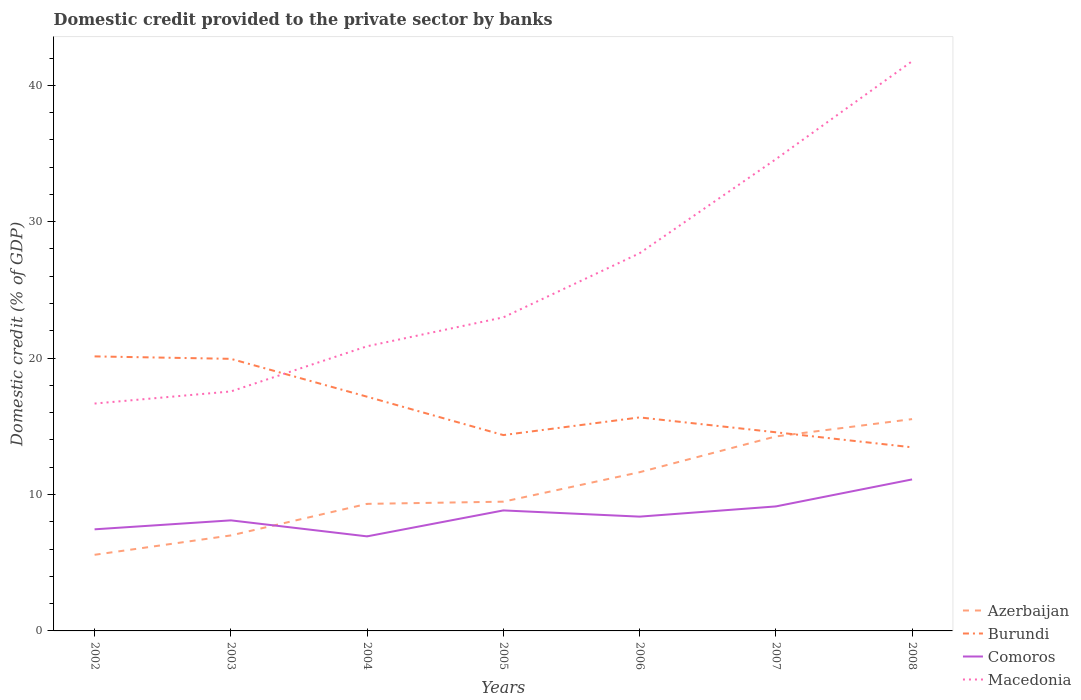How many different coloured lines are there?
Offer a terse response. 4. Across all years, what is the maximum domestic credit provided to the private sector by banks in Comoros?
Your response must be concise. 6.93. In which year was the domestic credit provided to the private sector by banks in Burundi maximum?
Offer a terse response. 2008. What is the total domestic credit provided to the private sector by banks in Comoros in the graph?
Your response must be concise. -1.39. What is the difference between the highest and the second highest domestic credit provided to the private sector by banks in Burundi?
Your answer should be very brief. 6.67. Is the domestic credit provided to the private sector by banks in Burundi strictly greater than the domestic credit provided to the private sector by banks in Comoros over the years?
Give a very brief answer. No. How many lines are there?
Provide a short and direct response. 4. Does the graph contain any zero values?
Your answer should be very brief. No. Does the graph contain grids?
Make the answer very short. No. Where does the legend appear in the graph?
Offer a terse response. Bottom right. How many legend labels are there?
Give a very brief answer. 4. How are the legend labels stacked?
Your answer should be very brief. Vertical. What is the title of the graph?
Ensure brevity in your answer.  Domestic credit provided to the private sector by banks. Does "Myanmar" appear as one of the legend labels in the graph?
Ensure brevity in your answer.  No. What is the label or title of the X-axis?
Offer a very short reply. Years. What is the label or title of the Y-axis?
Your answer should be compact. Domestic credit (% of GDP). What is the Domestic credit (% of GDP) in Azerbaijan in 2002?
Keep it short and to the point. 5.58. What is the Domestic credit (% of GDP) in Burundi in 2002?
Offer a terse response. 20.13. What is the Domestic credit (% of GDP) of Comoros in 2002?
Your answer should be compact. 7.45. What is the Domestic credit (% of GDP) of Macedonia in 2002?
Make the answer very short. 16.67. What is the Domestic credit (% of GDP) in Azerbaijan in 2003?
Give a very brief answer. 7. What is the Domestic credit (% of GDP) in Burundi in 2003?
Offer a terse response. 19.95. What is the Domestic credit (% of GDP) of Comoros in 2003?
Offer a very short reply. 8.11. What is the Domestic credit (% of GDP) in Macedonia in 2003?
Keep it short and to the point. 17.56. What is the Domestic credit (% of GDP) of Azerbaijan in 2004?
Provide a short and direct response. 9.31. What is the Domestic credit (% of GDP) in Burundi in 2004?
Give a very brief answer. 17.17. What is the Domestic credit (% of GDP) of Comoros in 2004?
Offer a terse response. 6.93. What is the Domestic credit (% of GDP) in Macedonia in 2004?
Offer a very short reply. 20.87. What is the Domestic credit (% of GDP) of Azerbaijan in 2005?
Offer a very short reply. 9.48. What is the Domestic credit (% of GDP) in Burundi in 2005?
Your answer should be compact. 14.36. What is the Domestic credit (% of GDP) of Comoros in 2005?
Offer a terse response. 8.83. What is the Domestic credit (% of GDP) in Macedonia in 2005?
Offer a terse response. 22.99. What is the Domestic credit (% of GDP) in Azerbaijan in 2006?
Your response must be concise. 11.64. What is the Domestic credit (% of GDP) in Burundi in 2006?
Give a very brief answer. 15.65. What is the Domestic credit (% of GDP) of Comoros in 2006?
Give a very brief answer. 8.38. What is the Domestic credit (% of GDP) of Macedonia in 2006?
Provide a short and direct response. 27.69. What is the Domestic credit (% of GDP) of Azerbaijan in 2007?
Offer a terse response. 14.26. What is the Domestic credit (% of GDP) in Burundi in 2007?
Your answer should be very brief. 14.56. What is the Domestic credit (% of GDP) in Comoros in 2007?
Your answer should be very brief. 9.13. What is the Domestic credit (% of GDP) of Macedonia in 2007?
Offer a terse response. 34.58. What is the Domestic credit (% of GDP) in Azerbaijan in 2008?
Ensure brevity in your answer.  15.53. What is the Domestic credit (% of GDP) in Burundi in 2008?
Offer a terse response. 13.46. What is the Domestic credit (% of GDP) of Comoros in 2008?
Your answer should be very brief. 11.11. What is the Domestic credit (% of GDP) of Macedonia in 2008?
Give a very brief answer. 41.76. Across all years, what is the maximum Domestic credit (% of GDP) of Azerbaijan?
Your answer should be compact. 15.53. Across all years, what is the maximum Domestic credit (% of GDP) in Burundi?
Provide a succinct answer. 20.13. Across all years, what is the maximum Domestic credit (% of GDP) of Comoros?
Ensure brevity in your answer.  11.11. Across all years, what is the maximum Domestic credit (% of GDP) of Macedonia?
Your answer should be compact. 41.76. Across all years, what is the minimum Domestic credit (% of GDP) of Azerbaijan?
Your answer should be very brief. 5.58. Across all years, what is the minimum Domestic credit (% of GDP) of Burundi?
Make the answer very short. 13.46. Across all years, what is the minimum Domestic credit (% of GDP) in Comoros?
Your answer should be very brief. 6.93. Across all years, what is the minimum Domestic credit (% of GDP) of Macedonia?
Ensure brevity in your answer.  16.67. What is the total Domestic credit (% of GDP) in Azerbaijan in the graph?
Your answer should be compact. 72.79. What is the total Domestic credit (% of GDP) of Burundi in the graph?
Your response must be concise. 115.28. What is the total Domestic credit (% of GDP) in Comoros in the graph?
Your response must be concise. 59.93. What is the total Domestic credit (% of GDP) of Macedonia in the graph?
Offer a terse response. 182.12. What is the difference between the Domestic credit (% of GDP) of Azerbaijan in 2002 and that in 2003?
Make the answer very short. -1.42. What is the difference between the Domestic credit (% of GDP) of Burundi in 2002 and that in 2003?
Make the answer very short. 0.18. What is the difference between the Domestic credit (% of GDP) of Comoros in 2002 and that in 2003?
Provide a succinct answer. -0.66. What is the difference between the Domestic credit (% of GDP) in Macedonia in 2002 and that in 2003?
Provide a short and direct response. -0.89. What is the difference between the Domestic credit (% of GDP) in Azerbaijan in 2002 and that in 2004?
Ensure brevity in your answer.  -3.73. What is the difference between the Domestic credit (% of GDP) of Burundi in 2002 and that in 2004?
Provide a succinct answer. 2.96. What is the difference between the Domestic credit (% of GDP) in Comoros in 2002 and that in 2004?
Make the answer very short. 0.52. What is the difference between the Domestic credit (% of GDP) of Macedonia in 2002 and that in 2004?
Keep it short and to the point. -4.2. What is the difference between the Domestic credit (% of GDP) of Azerbaijan in 2002 and that in 2005?
Keep it short and to the point. -3.89. What is the difference between the Domestic credit (% of GDP) in Burundi in 2002 and that in 2005?
Your answer should be compact. 5.77. What is the difference between the Domestic credit (% of GDP) in Comoros in 2002 and that in 2005?
Keep it short and to the point. -1.39. What is the difference between the Domestic credit (% of GDP) in Macedonia in 2002 and that in 2005?
Your answer should be very brief. -6.32. What is the difference between the Domestic credit (% of GDP) of Azerbaijan in 2002 and that in 2006?
Ensure brevity in your answer.  -6.05. What is the difference between the Domestic credit (% of GDP) in Burundi in 2002 and that in 2006?
Provide a short and direct response. 4.47. What is the difference between the Domestic credit (% of GDP) of Comoros in 2002 and that in 2006?
Provide a short and direct response. -0.93. What is the difference between the Domestic credit (% of GDP) of Macedonia in 2002 and that in 2006?
Offer a very short reply. -11.02. What is the difference between the Domestic credit (% of GDP) in Azerbaijan in 2002 and that in 2007?
Your answer should be very brief. -8.68. What is the difference between the Domestic credit (% of GDP) in Burundi in 2002 and that in 2007?
Keep it short and to the point. 5.56. What is the difference between the Domestic credit (% of GDP) in Comoros in 2002 and that in 2007?
Your answer should be compact. -1.68. What is the difference between the Domestic credit (% of GDP) of Macedonia in 2002 and that in 2007?
Your response must be concise. -17.91. What is the difference between the Domestic credit (% of GDP) in Azerbaijan in 2002 and that in 2008?
Offer a very short reply. -9.95. What is the difference between the Domestic credit (% of GDP) of Burundi in 2002 and that in 2008?
Provide a short and direct response. 6.67. What is the difference between the Domestic credit (% of GDP) in Comoros in 2002 and that in 2008?
Provide a succinct answer. -3.66. What is the difference between the Domestic credit (% of GDP) of Macedonia in 2002 and that in 2008?
Your answer should be compact. -25.09. What is the difference between the Domestic credit (% of GDP) in Azerbaijan in 2003 and that in 2004?
Your answer should be very brief. -2.31. What is the difference between the Domestic credit (% of GDP) of Burundi in 2003 and that in 2004?
Offer a very short reply. 2.78. What is the difference between the Domestic credit (% of GDP) in Comoros in 2003 and that in 2004?
Offer a terse response. 1.17. What is the difference between the Domestic credit (% of GDP) in Macedonia in 2003 and that in 2004?
Make the answer very short. -3.31. What is the difference between the Domestic credit (% of GDP) of Azerbaijan in 2003 and that in 2005?
Ensure brevity in your answer.  -2.47. What is the difference between the Domestic credit (% of GDP) of Burundi in 2003 and that in 2005?
Keep it short and to the point. 5.59. What is the difference between the Domestic credit (% of GDP) of Comoros in 2003 and that in 2005?
Your answer should be very brief. -0.73. What is the difference between the Domestic credit (% of GDP) of Macedonia in 2003 and that in 2005?
Keep it short and to the point. -5.43. What is the difference between the Domestic credit (% of GDP) of Azerbaijan in 2003 and that in 2006?
Offer a terse response. -4.63. What is the difference between the Domestic credit (% of GDP) in Burundi in 2003 and that in 2006?
Offer a terse response. 4.29. What is the difference between the Domestic credit (% of GDP) of Comoros in 2003 and that in 2006?
Provide a short and direct response. -0.27. What is the difference between the Domestic credit (% of GDP) in Macedonia in 2003 and that in 2006?
Make the answer very short. -10.13. What is the difference between the Domestic credit (% of GDP) of Azerbaijan in 2003 and that in 2007?
Keep it short and to the point. -7.26. What is the difference between the Domestic credit (% of GDP) in Burundi in 2003 and that in 2007?
Provide a succinct answer. 5.38. What is the difference between the Domestic credit (% of GDP) in Comoros in 2003 and that in 2007?
Offer a terse response. -1.02. What is the difference between the Domestic credit (% of GDP) of Macedonia in 2003 and that in 2007?
Your answer should be compact. -17.03. What is the difference between the Domestic credit (% of GDP) in Azerbaijan in 2003 and that in 2008?
Make the answer very short. -8.53. What is the difference between the Domestic credit (% of GDP) of Burundi in 2003 and that in 2008?
Keep it short and to the point. 6.49. What is the difference between the Domestic credit (% of GDP) in Comoros in 2003 and that in 2008?
Keep it short and to the point. -3. What is the difference between the Domestic credit (% of GDP) of Macedonia in 2003 and that in 2008?
Ensure brevity in your answer.  -24.21. What is the difference between the Domestic credit (% of GDP) of Azerbaijan in 2004 and that in 2005?
Ensure brevity in your answer.  -0.16. What is the difference between the Domestic credit (% of GDP) of Burundi in 2004 and that in 2005?
Make the answer very short. 2.81. What is the difference between the Domestic credit (% of GDP) of Comoros in 2004 and that in 2005?
Ensure brevity in your answer.  -1.9. What is the difference between the Domestic credit (% of GDP) in Macedonia in 2004 and that in 2005?
Give a very brief answer. -2.12. What is the difference between the Domestic credit (% of GDP) in Azerbaijan in 2004 and that in 2006?
Make the answer very short. -2.32. What is the difference between the Domestic credit (% of GDP) of Burundi in 2004 and that in 2006?
Your response must be concise. 1.52. What is the difference between the Domestic credit (% of GDP) in Comoros in 2004 and that in 2006?
Make the answer very short. -1.45. What is the difference between the Domestic credit (% of GDP) of Macedonia in 2004 and that in 2006?
Your answer should be very brief. -6.82. What is the difference between the Domestic credit (% of GDP) in Azerbaijan in 2004 and that in 2007?
Give a very brief answer. -4.94. What is the difference between the Domestic credit (% of GDP) in Burundi in 2004 and that in 2007?
Offer a terse response. 2.61. What is the difference between the Domestic credit (% of GDP) of Comoros in 2004 and that in 2007?
Provide a succinct answer. -2.2. What is the difference between the Domestic credit (% of GDP) in Macedonia in 2004 and that in 2007?
Ensure brevity in your answer.  -13.71. What is the difference between the Domestic credit (% of GDP) in Azerbaijan in 2004 and that in 2008?
Your answer should be very brief. -6.21. What is the difference between the Domestic credit (% of GDP) of Burundi in 2004 and that in 2008?
Keep it short and to the point. 3.71. What is the difference between the Domestic credit (% of GDP) of Comoros in 2004 and that in 2008?
Provide a short and direct response. -4.18. What is the difference between the Domestic credit (% of GDP) of Macedonia in 2004 and that in 2008?
Ensure brevity in your answer.  -20.9. What is the difference between the Domestic credit (% of GDP) of Azerbaijan in 2005 and that in 2006?
Provide a succinct answer. -2.16. What is the difference between the Domestic credit (% of GDP) of Burundi in 2005 and that in 2006?
Your answer should be compact. -1.3. What is the difference between the Domestic credit (% of GDP) of Comoros in 2005 and that in 2006?
Your answer should be compact. 0.45. What is the difference between the Domestic credit (% of GDP) in Macedonia in 2005 and that in 2006?
Your answer should be compact. -4.7. What is the difference between the Domestic credit (% of GDP) in Azerbaijan in 2005 and that in 2007?
Give a very brief answer. -4.78. What is the difference between the Domestic credit (% of GDP) of Burundi in 2005 and that in 2007?
Your response must be concise. -0.21. What is the difference between the Domestic credit (% of GDP) in Comoros in 2005 and that in 2007?
Offer a terse response. -0.29. What is the difference between the Domestic credit (% of GDP) in Macedonia in 2005 and that in 2007?
Offer a terse response. -11.6. What is the difference between the Domestic credit (% of GDP) in Azerbaijan in 2005 and that in 2008?
Make the answer very short. -6.05. What is the difference between the Domestic credit (% of GDP) of Burundi in 2005 and that in 2008?
Give a very brief answer. 0.9. What is the difference between the Domestic credit (% of GDP) of Comoros in 2005 and that in 2008?
Make the answer very short. -2.27. What is the difference between the Domestic credit (% of GDP) of Macedonia in 2005 and that in 2008?
Your response must be concise. -18.78. What is the difference between the Domestic credit (% of GDP) of Azerbaijan in 2006 and that in 2007?
Keep it short and to the point. -2.62. What is the difference between the Domestic credit (% of GDP) in Burundi in 2006 and that in 2007?
Offer a terse response. 1.09. What is the difference between the Domestic credit (% of GDP) in Comoros in 2006 and that in 2007?
Your response must be concise. -0.75. What is the difference between the Domestic credit (% of GDP) of Macedonia in 2006 and that in 2007?
Your answer should be compact. -6.89. What is the difference between the Domestic credit (% of GDP) in Azerbaijan in 2006 and that in 2008?
Provide a succinct answer. -3.89. What is the difference between the Domestic credit (% of GDP) of Burundi in 2006 and that in 2008?
Your answer should be very brief. 2.19. What is the difference between the Domestic credit (% of GDP) in Comoros in 2006 and that in 2008?
Offer a very short reply. -2.73. What is the difference between the Domestic credit (% of GDP) in Macedonia in 2006 and that in 2008?
Make the answer very short. -14.08. What is the difference between the Domestic credit (% of GDP) of Azerbaijan in 2007 and that in 2008?
Give a very brief answer. -1.27. What is the difference between the Domestic credit (% of GDP) of Burundi in 2007 and that in 2008?
Offer a terse response. 1.1. What is the difference between the Domestic credit (% of GDP) in Comoros in 2007 and that in 2008?
Offer a terse response. -1.98. What is the difference between the Domestic credit (% of GDP) of Macedonia in 2007 and that in 2008?
Your answer should be compact. -7.18. What is the difference between the Domestic credit (% of GDP) in Azerbaijan in 2002 and the Domestic credit (% of GDP) in Burundi in 2003?
Your response must be concise. -14.37. What is the difference between the Domestic credit (% of GDP) in Azerbaijan in 2002 and the Domestic credit (% of GDP) in Comoros in 2003?
Provide a succinct answer. -2.52. What is the difference between the Domestic credit (% of GDP) of Azerbaijan in 2002 and the Domestic credit (% of GDP) of Macedonia in 2003?
Provide a succinct answer. -11.98. What is the difference between the Domestic credit (% of GDP) of Burundi in 2002 and the Domestic credit (% of GDP) of Comoros in 2003?
Offer a terse response. 12.02. What is the difference between the Domestic credit (% of GDP) in Burundi in 2002 and the Domestic credit (% of GDP) in Macedonia in 2003?
Ensure brevity in your answer.  2.57. What is the difference between the Domestic credit (% of GDP) in Comoros in 2002 and the Domestic credit (% of GDP) in Macedonia in 2003?
Offer a very short reply. -10.11. What is the difference between the Domestic credit (% of GDP) of Azerbaijan in 2002 and the Domestic credit (% of GDP) of Burundi in 2004?
Your response must be concise. -11.59. What is the difference between the Domestic credit (% of GDP) of Azerbaijan in 2002 and the Domestic credit (% of GDP) of Comoros in 2004?
Offer a terse response. -1.35. What is the difference between the Domestic credit (% of GDP) in Azerbaijan in 2002 and the Domestic credit (% of GDP) in Macedonia in 2004?
Offer a terse response. -15.29. What is the difference between the Domestic credit (% of GDP) of Burundi in 2002 and the Domestic credit (% of GDP) of Comoros in 2004?
Ensure brevity in your answer.  13.19. What is the difference between the Domestic credit (% of GDP) of Burundi in 2002 and the Domestic credit (% of GDP) of Macedonia in 2004?
Keep it short and to the point. -0.74. What is the difference between the Domestic credit (% of GDP) of Comoros in 2002 and the Domestic credit (% of GDP) of Macedonia in 2004?
Your response must be concise. -13.42. What is the difference between the Domestic credit (% of GDP) of Azerbaijan in 2002 and the Domestic credit (% of GDP) of Burundi in 2005?
Give a very brief answer. -8.78. What is the difference between the Domestic credit (% of GDP) in Azerbaijan in 2002 and the Domestic credit (% of GDP) in Comoros in 2005?
Give a very brief answer. -3.25. What is the difference between the Domestic credit (% of GDP) in Azerbaijan in 2002 and the Domestic credit (% of GDP) in Macedonia in 2005?
Offer a terse response. -17.41. What is the difference between the Domestic credit (% of GDP) of Burundi in 2002 and the Domestic credit (% of GDP) of Comoros in 2005?
Your answer should be very brief. 11.29. What is the difference between the Domestic credit (% of GDP) of Burundi in 2002 and the Domestic credit (% of GDP) of Macedonia in 2005?
Provide a succinct answer. -2.86. What is the difference between the Domestic credit (% of GDP) of Comoros in 2002 and the Domestic credit (% of GDP) of Macedonia in 2005?
Keep it short and to the point. -15.54. What is the difference between the Domestic credit (% of GDP) in Azerbaijan in 2002 and the Domestic credit (% of GDP) in Burundi in 2006?
Your answer should be very brief. -10.07. What is the difference between the Domestic credit (% of GDP) in Azerbaijan in 2002 and the Domestic credit (% of GDP) in Comoros in 2006?
Your response must be concise. -2.8. What is the difference between the Domestic credit (% of GDP) of Azerbaijan in 2002 and the Domestic credit (% of GDP) of Macedonia in 2006?
Make the answer very short. -22.11. What is the difference between the Domestic credit (% of GDP) in Burundi in 2002 and the Domestic credit (% of GDP) in Comoros in 2006?
Make the answer very short. 11.75. What is the difference between the Domestic credit (% of GDP) of Burundi in 2002 and the Domestic credit (% of GDP) of Macedonia in 2006?
Offer a terse response. -7.56. What is the difference between the Domestic credit (% of GDP) in Comoros in 2002 and the Domestic credit (% of GDP) in Macedonia in 2006?
Your answer should be very brief. -20.24. What is the difference between the Domestic credit (% of GDP) of Azerbaijan in 2002 and the Domestic credit (% of GDP) of Burundi in 2007?
Your answer should be compact. -8.98. What is the difference between the Domestic credit (% of GDP) in Azerbaijan in 2002 and the Domestic credit (% of GDP) in Comoros in 2007?
Offer a very short reply. -3.55. What is the difference between the Domestic credit (% of GDP) in Azerbaijan in 2002 and the Domestic credit (% of GDP) in Macedonia in 2007?
Keep it short and to the point. -29. What is the difference between the Domestic credit (% of GDP) in Burundi in 2002 and the Domestic credit (% of GDP) in Comoros in 2007?
Make the answer very short. 11. What is the difference between the Domestic credit (% of GDP) of Burundi in 2002 and the Domestic credit (% of GDP) of Macedonia in 2007?
Make the answer very short. -14.46. What is the difference between the Domestic credit (% of GDP) of Comoros in 2002 and the Domestic credit (% of GDP) of Macedonia in 2007?
Keep it short and to the point. -27.13. What is the difference between the Domestic credit (% of GDP) in Azerbaijan in 2002 and the Domestic credit (% of GDP) in Burundi in 2008?
Keep it short and to the point. -7.88. What is the difference between the Domestic credit (% of GDP) of Azerbaijan in 2002 and the Domestic credit (% of GDP) of Comoros in 2008?
Your answer should be very brief. -5.53. What is the difference between the Domestic credit (% of GDP) of Azerbaijan in 2002 and the Domestic credit (% of GDP) of Macedonia in 2008?
Provide a succinct answer. -36.18. What is the difference between the Domestic credit (% of GDP) of Burundi in 2002 and the Domestic credit (% of GDP) of Comoros in 2008?
Offer a terse response. 9.02. What is the difference between the Domestic credit (% of GDP) of Burundi in 2002 and the Domestic credit (% of GDP) of Macedonia in 2008?
Offer a very short reply. -21.64. What is the difference between the Domestic credit (% of GDP) in Comoros in 2002 and the Domestic credit (% of GDP) in Macedonia in 2008?
Ensure brevity in your answer.  -34.32. What is the difference between the Domestic credit (% of GDP) in Azerbaijan in 2003 and the Domestic credit (% of GDP) in Burundi in 2004?
Your answer should be very brief. -10.17. What is the difference between the Domestic credit (% of GDP) in Azerbaijan in 2003 and the Domestic credit (% of GDP) in Comoros in 2004?
Give a very brief answer. 0.07. What is the difference between the Domestic credit (% of GDP) in Azerbaijan in 2003 and the Domestic credit (% of GDP) in Macedonia in 2004?
Make the answer very short. -13.87. What is the difference between the Domestic credit (% of GDP) of Burundi in 2003 and the Domestic credit (% of GDP) of Comoros in 2004?
Your response must be concise. 13.02. What is the difference between the Domestic credit (% of GDP) of Burundi in 2003 and the Domestic credit (% of GDP) of Macedonia in 2004?
Offer a very short reply. -0.92. What is the difference between the Domestic credit (% of GDP) of Comoros in 2003 and the Domestic credit (% of GDP) of Macedonia in 2004?
Ensure brevity in your answer.  -12.76. What is the difference between the Domestic credit (% of GDP) of Azerbaijan in 2003 and the Domestic credit (% of GDP) of Burundi in 2005?
Provide a succinct answer. -7.36. What is the difference between the Domestic credit (% of GDP) of Azerbaijan in 2003 and the Domestic credit (% of GDP) of Comoros in 2005?
Provide a short and direct response. -1.83. What is the difference between the Domestic credit (% of GDP) in Azerbaijan in 2003 and the Domestic credit (% of GDP) in Macedonia in 2005?
Your answer should be very brief. -15.99. What is the difference between the Domestic credit (% of GDP) in Burundi in 2003 and the Domestic credit (% of GDP) in Comoros in 2005?
Provide a succinct answer. 11.11. What is the difference between the Domestic credit (% of GDP) of Burundi in 2003 and the Domestic credit (% of GDP) of Macedonia in 2005?
Provide a short and direct response. -3.04. What is the difference between the Domestic credit (% of GDP) in Comoros in 2003 and the Domestic credit (% of GDP) in Macedonia in 2005?
Keep it short and to the point. -14.88. What is the difference between the Domestic credit (% of GDP) in Azerbaijan in 2003 and the Domestic credit (% of GDP) in Burundi in 2006?
Offer a very short reply. -8.65. What is the difference between the Domestic credit (% of GDP) of Azerbaijan in 2003 and the Domestic credit (% of GDP) of Comoros in 2006?
Provide a short and direct response. -1.38. What is the difference between the Domestic credit (% of GDP) of Azerbaijan in 2003 and the Domestic credit (% of GDP) of Macedonia in 2006?
Offer a very short reply. -20.69. What is the difference between the Domestic credit (% of GDP) of Burundi in 2003 and the Domestic credit (% of GDP) of Comoros in 2006?
Your answer should be very brief. 11.57. What is the difference between the Domestic credit (% of GDP) in Burundi in 2003 and the Domestic credit (% of GDP) in Macedonia in 2006?
Ensure brevity in your answer.  -7.74. What is the difference between the Domestic credit (% of GDP) of Comoros in 2003 and the Domestic credit (% of GDP) of Macedonia in 2006?
Your response must be concise. -19.58. What is the difference between the Domestic credit (% of GDP) of Azerbaijan in 2003 and the Domestic credit (% of GDP) of Burundi in 2007?
Make the answer very short. -7.56. What is the difference between the Domestic credit (% of GDP) in Azerbaijan in 2003 and the Domestic credit (% of GDP) in Comoros in 2007?
Give a very brief answer. -2.13. What is the difference between the Domestic credit (% of GDP) of Azerbaijan in 2003 and the Domestic credit (% of GDP) of Macedonia in 2007?
Offer a terse response. -27.58. What is the difference between the Domestic credit (% of GDP) in Burundi in 2003 and the Domestic credit (% of GDP) in Comoros in 2007?
Your answer should be very brief. 10.82. What is the difference between the Domestic credit (% of GDP) in Burundi in 2003 and the Domestic credit (% of GDP) in Macedonia in 2007?
Your answer should be compact. -14.64. What is the difference between the Domestic credit (% of GDP) in Comoros in 2003 and the Domestic credit (% of GDP) in Macedonia in 2007?
Keep it short and to the point. -26.48. What is the difference between the Domestic credit (% of GDP) in Azerbaijan in 2003 and the Domestic credit (% of GDP) in Burundi in 2008?
Your answer should be compact. -6.46. What is the difference between the Domestic credit (% of GDP) of Azerbaijan in 2003 and the Domestic credit (% of GDP) of Comoros in 2008?
Your answer should be very brief. -4.11. What is the difference between the Domestic credit (% of GDP) in Azerbaijan in 2003 and the Domestic credit (% of GDP) in Macedonia in 2008?
Provide a succinct answer. -34.76. What is the difference between the Domestic credit (% of GDP) of Burundi in 2003 and the Domestic credit (% of GDP) of Comoros in 2008?
Your answer should be compact. 8.84. What is the difference between the Domestic credit (% of GDP) of Burundi in 2003 and the Domestic credit (% of GDP) of Macedonia in 2008?
Keep it short and to the point. -21.82. What is the difference between the Domestic credit (% of GDP) in Comoros in 2003 and the Domestic credit (% of GDP) in Macedonia in 2008?
Provide a succinct answer. -33.66. What is the difference between the Domestic credit (% of GDP) in Azerbaijan in 2004 and the Domestic credit (% of GDP) in Burundi in 2005?
Ensure brevity in your answer.  -5.04. What is the difference between the Domestic credit (% of GDP) in Azerbaijan in 2004 and the Domestic credit (% of GDP) in Comoros in 2005?
Provide a succinct answer. 0.48. What is the difference between the Domestic credit (% of GDP) in Azerbaijan in 2004 and the Domestic credit (% of GDP) in Macedonia in 2005?
Make the answer very short. -13.67. What is the difference between the Domestic credit (% of GDP) in Burundi in 2004 and the Domestic credit (% of GDP) in Comoros in 2005?
Provide a succinct answer. 8.34. What is the difference between the Domestic credit (% of GDP) of Burundi in 2004 and the Domestic credit (% of GDP) of Macedonia in 2005?
Give a very brief answer. -5.82. What is the difference between the Domestic credit (% of GDP) of Comoros in 2004 and the Domestic credit (% of GDP) of Macedonia in 2005?
Your answer should be compact. -16.06. What is the difference between the Domestic credit (% of GDP) in Azerbaijan in 2004 and the Domestic credit (% of GDP) in Burundi in 2006?
Your response must be concise. -6.34. What is the difference between the Domestic credit (% of GDP) in Azerbaijan in 2004 and the Domestic credit (% of GDP) in Comoros in 2006?
Provide a succinct answer. 0.94. What is the difference between the Domestic credit (% of GDP) in Azerbaijan in 2004 and the Domestic credit (% of GDP) in Macedonia in 2006?
Provide a short and direct response. -18.37. What is the difference between the Domestic credit (% of GDP) of Burundi in 2004 and the Domestic credit (% of GDP) of Comoros in 2006?
Give a very brief answer. 8.79. What is the difference between the Domestic credit (% of GDP) in Burundi in 2004 and the Domestic credit (% of GDP) in Macedonia in 2006?
Provide a short and direct response. -10.52. What is the difference between the Domestic credit (% of GDP) in Comoros in 2004 and the Domestic credit (% of GDP) in Macedonia in 2006?
Keep it short and to the point. -20.76. What is the difference between the Domestic credit (% of GDP) of Azerbaijan in 2004 and the Domestic credit (% of GDP) of Burundi in 2007?
Offer a terse response. -5.25. What is the difference between the Domestic credit (% of GDP) in Azerbaijan in 2004 and the Domestic credit (% of GDP) in Comoros in 2007?
Ensure brevity in your answer.  0.19. What is the difference between the Domestic credit (% of GDP) of Azerbaijan in 2004 and the Domestic credit (% of GDP) of Macedonia in 2007?
Offer a terse response. -25.27. What is the difference between the Domestic credit (% of GDP) of Burundi in 2004 and the Domestic credit (% of GDP) of Comoros in 2007?
Make the answer very short. 8.04. What is the difference between the Domestic credit (% of GDP) in Burundi in 2004 and the Domestic credit (% of GDP) in Macedonia in 2007?
Your response must be concise. -17.41. What is the difference between the Domestic credit (% of GDP) in Comoros in 2004 and the Domestic credit (% of GDP) in Macedonia in 2007?
Provide a succinct answer. -27.65. What is the difference between the Domestic credit (% of GDP) in Azerbaijan in 2004 and the Domestic credit (% of GDP) in Burundi in 2008?
Keep it short and to the point. -4.15. What is the difference between the Domestic credit (% of GDP) of Azerbaijan in 2004 and the Domestic credit (% of GDP) of Comoros in 2008?
Offer a very short reply. -1.79. What is the difference between the Domestic credit (% of GDP) in Azerbaijan in 2004 and the Domestic credit (% of GDP) in Macedonia in 2008?
Your answer should be compact. -32.45. What is the difference between the Domestic credit (% of GDP) of Burundi in 2004 and the Domestic credit (% of GDP) of Comoros in 2008?
Your answer should be very brief. 6.06. What is the difference between the Domestic credit (% of GDP) in Burundi in 2004 and the Domestic credit (% of GDP) in Macedonia in 2008?
Keep it short and to the point. -24.59. What is the difference between the Domestic credit (% of GDP) of Comoros in 2004 and the Domestic credit (% of GDP) of Macedonia in 2008?
Keep it short and to the point. -34.83. What is the difference between the Domestic credit (% of GDP) in Azerbaijan in 2005 and the Domestic credit (% of GDP) in Burundi in 2006?
Ensure brevity in your answer.  -6.18. What is the difference between the Domestic credit (% of GDP) in Azerbaijan in 2005 and the Domestic credit (% of GDP) in Comoros in 2006?
Make the answer very short. 1.1. What is the difference between the Domestic credit (% of GDP) in Azerbaijan in 2005 and the Domestic credit (% of GDP) in Macedonia in 2006?
Give a very brief answer. -18.21. What is the difference between the Domestic credit (% of GDP) in Burundi in 2005 and the Domestic credit (% of GDP) in Comoros in 2006?
Ensure brevity in your answer.  5.98. What is the difference between the Domestic credit (% of GDP) of Burundi in 2005 and the Domestic credit (% of GDP) of Macedonia in 2006?
Make the answer very short. -13.33. What is the difference between the Domestic credit (% of GDP) of Comoros in 2005 and the Domestic credit (% of GDP) of Macedonia in 2006?
Your response must be concise. -18.85. What is the difference between the Domestic credit (% of GDP) of Azerbaijan in 2005 and the Domestic credit (% of GDP) of Burundi in 2007?
Ensure brevity in your answer.  -5.09. What is the difference between the Domestic credit (% of GDP) of Azerbaijan in 2005 and the Domestic credit (% of GDP) of Comoros in 2007?
Your answer should be compact. 0.35. What is the difference between the Domestic credit (% of GDP) of Azerbaijan in 2005 and the Domestic credit (% of GDP) of Macedonia in 2007?
Make the answer very short. -25.11. What is the difference between the Domestic credit (% of GDP) in Burundi in 2005 and the Domestic credit (% of GDP) in Comoros in 2007?
Ensure brevity in your answer.  5.23. What is the difference between the Domestic credit (% of GDP) of Burundi in 2005 and the Domestic credit (% of GDP) of Macedonia in 2007?
Offer a very short reply. -20.23. What is the difference between the Domestic credit (% of GDP) in Comoros in 2005 and the Domestic credit (% of GDP) in Macedonia in 2007?
Provide a succinct answer. -25.75. What is the difference between the Domestic credit (% of GDP) of Azerbaijan in 2005 and the Domestic credit (% of GDP) of Burundi in 2008?
Provide a short and direct response. -3.99. What is the difference between the Domestic credit (% of GDP) of Azerbaijan in 2005 and the Domestic credit (% of GDP) of Comoros in 2008?
Offer a very short reply. -1.63. What is the difference between the Domestic credit (% of GDP) in Azerbaijan in 2005 and the Domestic credit (% of GDP) in Macedonia in 2008?
Offer a terse response. -32.29. What is the difference between the Domestic credit (% of GDP) of Burundi in 2005 and the Domestic credit (% of GDP) of Comoros in 2008?
Keep it short and to the point. 3.25. What is the difference between the Domestic credit (% of GDP) of Burundi in 2005 and the Domestic credit (% of GDP) of Macedonia in 2008?
Your response must be concise. -27.41. What is the difference between the Domestic credit (% of GDP) in Comoros in 2005 and the Domestic credit (% of GDP) in Macedonia in 2008?
Your answer should be compact. -32.93. What is the difference between the Domestic credit (% of GDP) in Azerbaijan in 2006 and the Domestic credit (% of GDP) in Burundi in 2007?
Offer a very short reply. -2.93. What is the difference between the Domestic credit (% of GDP) of Azerbaijan in 2006 and the Domestic credit (% of GDP) of Comoros in 2007?
Offer a terse response. 2.51. What is the difference between the Domestic credit (% of GDP) in Azerbaijan in 2006 and the Domestic credit (% of GDP) in Macedonia in 2007?
Give a very brief answer. -22.95. What is the difference between the Domestic credit (% of GDP) in Burundi in 2006 and the Domestic credit (% of GDP) in Comoros in 2007?
Ensure brevity in your answer.  6.53. What is the difference between the Domestic credit (% of GDP) of Burundi in 2006 and the Domestic credit (% of GDP) of Macedonia in 2007?
Your response must be concise. -18.93. What is the difference between the Domestic credit (% of GDP) of Comoros in 2006 and the Domestic credit (% of GDP) of Macedonia in 2007?
Offer a very short reply. -26.2. What is the difference between the Domestic credit (% of GDP) in Azerbaijan in 2006 and the Domestic credit (% of GDP) in Burundi in 2008?
Keep it short and to the point. -1.83. What is the difference between the Domestic credit (% of GDP) of Azerbaijan in 2006 and the Domestic credit (% of GDP) of Comoros in 2008?
Your answer should be compact. 0.53. What is the difference between the Domestic credit (% of GDP) in Azerbaijan in 2006 and the Domestic credit (% of GDP) in Macedonia in 2008?
Offer a very short reply. -30.13. What is the difference between the Domestic credit (% of GDP) of Burundi in 2006 and the Domestic credit (% of GDP) of Comoros in 2008?
Offer a terse response. 4.55. What is the difference between the Domestic credit (% of GDP) of Burundi in 2006 and the Domestic credit (% of GDP) of Macedonia in 2008?
Give a very brief answer. -26.11. What is the difference between the Domestic credit (% of GDP) of Comoros in 2006 and the Domestic credit (% of GDP) of Macedonia in 2008?
Provide a succinct answer. -33.38. What is the difference between the Domestic credit (% of GDP) of Azerbaijan in 2007 and the Domestic credit (% of GDP) of Burundi in 2008?
Provide a succinct answer. 0.8. What is the difference between the Domestic credit (% of GDP) in Azerbaijan in 2007 and the Domestic credit (% of GDP) in Comoros in 2008?
Offer a terse response. 3.15. What is the difference between the Domestic credit (% of GDP) in Azerbaijan in 2007 and the Domestic credit (% of GDP) in Macedonia in 2008?
Ensure brevity in your answer.  -27.51. What is the difference between the Domestic credit (% of GDP) in Burundi in 2007 and the Domestic credit (% of GDP) in Comoros in 2008?
Your response must be concise. 3.46. What is the difference between the Domestic credit (% of GDP) of Burundi in 2007 and the Domestic credit (% of GDP) of Macedonia in 2008?
Offer a terse response. -27.2. What is the difference between the Domestic credit (% of GDP) of Comoros in 2007 and the Domestic credit (% of GDP) of Macedonia in 2008?
Provide a succinct answer. -32.64. What is the average Domestic credit (% of GDP) of Azerbaijan per year?
Make the answer very short. 10.4. What is the average Domestic credit (% of GDP) in Burundi per year?
Offer a terse response. 16.47. What is the average Domestic credit (% of GDP) of Comoros per year?
Your answer should be compact. 8.56. What is the average Domestic credit (% of GDP) of Macedonia per year?
Give a very brief answer. 26.02. In the year 2002, what is the difference between the Domestic credit (% of GDP) of Azerbaijan and Domestic credit (% of GDP) of Burundi?
Offer a terse response. -14.55. In the year 2002, what is the difference between the Domestic credit (% of GDP) of Azerbaijan and Domestic credit (% of GDP) of Comoros?
Give a very brief answer. -1.87. In the year 2002, what is the difference between the Domestic credit (% of GDP) in Azerbaijan and Domestic credit (% of GDP) in Macedonia?
Offer a very short reply. -11.09. In the year 2002, what is the difference between the Domestic credit (% of GDP) of Burundi and Domestic credit (% of GDP) of Comoros?
Give a very brief answer. 12.68. In the year 2002, what is the difference between the Domestic credit (% of GDP) in Burundi and Domestic credit (% of GDP) in Macedonia?
Make the answer very short. 3.46. In the year 2002, what is the difference between the Domestic credit (% of GDP) in Comoros and Domestic credit (% of GDP) in Macedonia?
Offer a terse response. -9.22. In the year 2003, what is the difference between the Domestic credit (% of GDP) in Azerbaijan and Domestic credit (% of GDP) in Burundi?
Your answer should be compact. -12.95. In the year 2003, what is the difference between the Domestic credit (% of GDP) of Azerbaijan and Domestic credit (% of GDP) of Comoros?
Offer a very short reply. -1.1. In the year 2003, what is the difference between the Domestic credit (% of GDP) in Azerbaijan and Domestic credit (% of GDP) in Macedonia?
Provide a succinct answer. -10.56. In the year 2003, what is the difference between the Domestic credit (% of GDP) in Burundi and Domestic credit (% of GDP) in Comoros?
Keep it short and to the point. 11.84. In the year 2003, what is the difference between the Domestic credit (% of GDP) of Burundi and Domestic credit (% of GDP) of Macedonia?
Keep it short and to the point. 2.39. In the year 2003, what is the difference between the Domestic credit (% of GDP) of Comoros and Domestic credit (% of GDP) of Macedonia?
Your answer should be very brief. -9.45. In the year 2004, what is the difference between the Domestic credit (% of GDP) in Azerbaijan and Domestic credit (% of GDP) in Burundi?
Offer a very short reply. -7.86. In the year 2004, what is the difference between the Domestic credit (% of GDP) of Azerbaijan and Domestic credit (% of GDP) of Comoros?
Provide a short and direct response. 2.38. In the year 2004, what is the difference between the Domestic credit (% of GDP) of Azerbaijan and Domestic credit (% of GDP) of Macedonia?
Your response must be concise. -11.55. In the year 2004, what is the difference between the Domestic credit (% of GDP) in Burundi and Domestic credit (% of GDP) in Comoros?
Offer a very short reply. 10.24. In the year 2004, what is the difference between the Domestic credit (% of GDP) in Burundi and Domestic credit (% of GDP) in Macedonia?
Ensure brevity in your answer.  -3.7. In the year 2004, what is the difference between the Domestic credit (% of GDP) of Comoros and Domestic credit (% of GDP) of Macedonia?
Ensure brevity in your answer.  -13.94. In the year 2005, what is the difference between the Domestic credit (% of GDP) of Azerbaijan and Domestic credit (% of GDP) of Burundi?
Give a very brief answer. -4.88. In the year 2005, what is the difference between the Domestic credit (% of GDP) in Azerbaijan and Domestic credit (% of GDP) in Comoros?
Your response must be concise. 0.64. In the year 2005, what is the difference between the Domestic credit (% of GDP) in Azerbaijan and Domestic credit (% of GDP) in Macedonia?
Give a very brief answer. -13.51. In the year 2005, what is the difference between the Domestic credit (% of GDP) of Burundi and Domestic credit (% of GDP) of Comoros?
Keep it short and to the point. 5.52. In the year 2005, what is the difference between the Domestic credit (% of GDP) of Burundi and Domestic credit (% of GDP) of Macedonia?
Your answer should be compact. -8.63. In the year 2005, what is the difference between the Domestic credit (% of GDP) of Comoros and Domestic credit (% of GDP) of Macedonia?
Offer a terse response. -14.15. In the year 2006, what is the difference between the Domestic credit (% of GDP) of Azerbaijan and Domestic credit (% of GDP) of Burundi?
Provide a short and direct response. -4.02. In the year 2006, what is the difference between the Domestic credit (% of GDP) in Azerbaijan and Domestic credit (% of GDP) in Comoros?
Ensure brevity in your answer.  3.26. In the year 2006, what is the difference between the Domestic credit (% of GDP) of Azerbaijan and Domestic credit (% of GDP) of Macedonia?
Offer a very short reply. -16.05. In the year 2006, what is the difference between the Domestic credit (% of GDP) in Burundi and Domestic credit (% of GDP) in Comoros?
Provide a succinct answer. 7.27. In the year 2006, what is the difference between the Domestic credit (% of GDP) in Burundi and Domestic credit (% of GDP) in Macedonia?
Offer a terse response. -12.04. In the year 2006, what is the difference between the Domestic credit (% of GDP) of Comoros and Domestic credit (% of GDP) of Macedonia?
Provide a short and direct response. -19.31. In the year 2007, what is the difference between the Domestic credit (% of GDP) in Azerbaijan and Domestic credit (% of GDP) in Burundi?
Provide a succinct answer. -0.3. In the year 2007, what is the difference between the Domestic credit (% of GDP) in Azerbaijan and Domestic credit (% of GDP) in Comoros?
Your answer should be very brief. 5.13. In the year 2007, what is the difference between the Domestic credit (% of GDP) in Azerbaijan and Domestic credit (% of GDP) in Macedonia?
Provide a succinct answer. -20.32. In the year 2007, what is the difference between the Domestic credit (% of GDP) of Burundi and Domestic credit (% of GDP) of Comoros?
Your answer should be very brief. 5.44. In the year 2007, what is the difference between the Domestic credit (% of GDP) of Burundi and Domestic credit (% of GDP) of Macedonia?
Offer a very short reply. -20.02. In the year 2007, what is the difference between the Domestic credit (% of GDP) in Comoros and Domestic credit (% of GDP) in Macedonia?
Keep it short and to the point. -25.46. In the year 2008, what is the difference between the Domestic credit (% of GDP) in Azerbaijan and Domestic credit (% of GDP) in Burundi?
Keep it short and to the point. 2.07. In the year 2008, what is the difference between the Domestic credit (% of GDP) of Azerbaijan and Domestic credit (% of GDP) of Comoros?
Make the answer very short. 4.42. In the year 2008, what is the difference between the Domestic credit (% of GDP) in Azerbaijan and Domestic credit (% of GDP) in Macedonia?
Provide a short and direct response. -26.24. In the year 2008, what is the difference between the Domestic credit (% of GDP) of Burundi and Domestic credit (% of GDP) of Comoros?
Your answer should be very brief. 2.35. In the year 2008, what is the difference between the Domestic credit (% of GDP) of Burundi and Domestic credit (% of GDP) of Macedonia?
Your answer should be very brief. -28.3. In the year 2008, what is the difference between the Domestic credit (% of GDP) in Comoros and Domestic credit (% of GDP) in Macedonia?
Your response must be concise. -30.66. What is the ratio of the Domestic credit (% of GDP) of Azerbaijan in 2002 to that in 2003?
Offer a terse response. 0.8. What is the ratio of the Domestic credit (% of GDP) of Comoros in 2002 to that in 2003?
Offer a very short reply. 0.92. What is the ratio of the Domestic credit (% of GDP) of Macedonia in 2002 to that in 2003?
Ensure brevity in your answer.  0.95. What is the ratio of the Domestic credit (% of GDP) in Azerbaijan in 2002 to that in 2004?
Provide a succinct answer. 0.6. What is the ratio of the Domestic credit (% of GDP) of Burundi in 2002 to that in 2004?
Keep it short and to the point. 1.17. What is the ratio of the Domestic credit (% of GDP) in Comoros in 2002 to that in 2004?
Offer a terse response. 1.07. What is the ratio of the Domestic credit (% of GDP) in Macedonia in 2002 to that in 2004?
Offer a terse response. 0.8. What is the ratio of the Domestic credit (% of GDP) of Azerbaijan in 2002 to that in 2005?
Keep it short and to the point. 0.59. What is the ratio of the Domestic credit (% of GDP) of Burundi in 2002 to that in 2005?
Give a very brief answer. 1.4. What is the ratio of the Domestic credit (% of GDP) in Comoros in 2002 to that in 2005?
Offer a terse response. 0.84. What is the ratio of the Domestic credit (% of GDP) of Macedonia in 2002 to that in 2005?
Make the answer very short. 0.73. What is the ratio of the Domestic credit (% of GDP) in Azerbaijan in 2002 to that in 2006?
Your response must be concise. 0.48. What is the ratio of the Domestic credit (% of GDP) in Burundi in 2002 to that in 2006?
Make the answer very short. 1.29. What is the ratio of the Domestic credit (% of GDP) in Comoros in 2002 to that in 2006?
Your response must be concise. 0.89. What is the ratio of the Domestic credit (% of GDP) in Macedonia in 2002 to that in 2006?
Provide a succinct answer. 0.6. What is the ratio of the Domestic credit (% of GDP) in Azerbaijan in 2002 to that in 2007?
Your response must be concise. 0.39. What is the ratio of the Domestic credit (% of GDP) in Burundi in 2002 to that in 2007?
Give a very brief answer. 1.38. What is the ratio of the Domestic credit (% of GDP) in Comoros in 2002 to that in 2007?
Your answer should be compact. 0.82. What is the ratio of the Domestic credit (% of GDP) in Macedonia in 2002 to that in 2007?
Offer a very short reply. 0.48. What is the ratio of the Domestic credit (% of GDP) of Azerbaijan in 2002 to that in 2008?
Give a very brief answer. 0.36. What is the ratio of the Domestic credit (% of GDP) of Burundi in 2002 to that in 2008?
Provide a short and direct response. 1.5. What is the ratio of the Domestic credit (% of GDP) in Comoros in 2002 to that in 2008?
Provide a short and direct response. 0.67. What is the ratio of the Domestic credit (% of GDP) in Macedonia in 2002 to that in 2008?
Offer a terse response. 0.4. What is the ratio of the Domestic credit (% of GDP) in Azerbaijan in 2003 to that in 2004?
Provide a short and direct response. 0.75. What is the ratio of the Domestic credit (% of GDP) of Burundi in 2003 to that in 2004?
Give a very brief answer. 1.16. What is the ratio of the Domestic credit (% of GDP) in Comoros in 2003 to that in 2004?
Keep it short and to the point. 1.17. What is the ratio of the Domestic credit (% of GDP) of Macedonia in 2003 to that in 2004?
Give a very brief answer. 0.84. What is the ratio of the Domestic credit (% of GDP) of Azerbaijan in 2003 to that in 2005?
Offer a terse response. 0.74. What is the ratio of the Domestic credit (% of GDP) in Burundi in 2003 to that in 2005?
Your answer should be compact. 1.39. What is the ratio of the Domestic credit (% of GDP) of Comoros in 2003 to that in 2005?
Provide a short and direct response. 0.92. What is the ratio of the Domestic credit (% of GDP) of Macedonia in 2003 to that in 2005?
Offer a very short reply. 0.76. What is the ratio of the Domestic credit (% of GDP) of Azerbaijan in 2003 to that in 2006?
Make the answer very short. 0.6. What is the ratio of the Domestic credit (% of GDP) of Burundi in 2003 to that in 2006?
Your response must be concise. 1.27. What is the ratio of the Domestic credit (% of GDP) of Comoros in 2003 to that in 2006?
Provide a succinct answer. 0.97. What is the ratio of the Domestic credit (% of GDP) of Macedonia in 2003 to that in 2006?
Make the answer very short. 0.63. What is the ratio of the Domestic credit (% of GDP) in Azerbaijan in 2003 to that in 2007?
Offer a terse response. 0.49. What is the ratio of the Domestic credit (% of GDP) in Burundi in 2003 to that in 2007?
Offer a terse response. 1.37. What is the ratio of the Domestic credit (% of GDP) of Comoros in 2003 to that in 2007?
Your answer should be compact. 0.89. What is the ratio of the Domestic credit (% of GDP) in Macedonia in 2003 to that in 2007?
Make the answer very short. 0.51. What is the ratio of the Domestic credit (% of GDP) of Azerbaijan in 2003 to that in 2008?
Your answer should be very brief. 0.45. What is the ratio of the Domestic credit (% of GDP) of Burundi in 2003 to that in 2008?
Keep it short and to the point. 1.48. What is the ratio of the Domestic credit (% of GDP) of Comoros in 2003 to that in 2008?
Make the answer very short. 0.73. What is the ratio of the Domestic credit (% of GDP) of Macedonia in 2003 to that in 2008?
Your response must be concise. 0.42. What is the ratio of the Domestic credit (% of GDP) of Burundi in 2004 to that in 2005?
Keep it short and to the point. 1.2. What is the ratio of the Domestic credit (% of GDP) in Comoros in 2004 to that in 2005?
Provide a succinct answer. 0.78. What is the ratio of the Domestic credit (% of GDP) in Macedonia in 2004 to that in 2005?
Offer a very short reply. 0.91. What is the ratio of the Domestic credit (% of GDP) in Azerbaijan in 2004 to that in 2006?
Your response must be concise. 0.8. What is the ratio of the Domestic credit (% of GDP) of Burundi in 2004 to that in 2006?
Ensure brevity in your answer.  1.1. What is the ratio of the Domestic credit (% of GDP) of Comoros in 2004 to that in 2006?
Your response must be concise. 0.83. What is the ratio of the Domestic credit (% of GDP) in Macedonia in 2004 to that in 2006?
Provide a short and direct response. 0.75. What is the ratio of the Domestic credit (% of GDP) in Azerbaijan in 2004 to that in 2007?
Make the answer very short. 0.65. What is the ratio of the Domestic credit (% of GDP) in Burundi in 2004 to that in 2007?
Make the answer very short. 1.18. What is the ratio of the Domestic credit (% of GDP) in Comoros in 2004 to that in 2007?
Keep it short and to the point. 0.76. What is the ratio of the Domestic credit (% of GDP) in Macedonia in 2004 to that in 2007?
Provide a short and direct response. 0.6. What is the ratio of the Domestic credit (% of GDP) in Azerbaijan in 2004 to that in 2008?
Provide a short and direct response. 0.6. What is the ratio of the Domestic credit (% of GDP) in Burundi in 2004 to that in 2008?
Make the answer very short. 1.28. What is the ratio of the Domestic credit (% of GDP) in Comoros in 2004 to that in 2008?
Offer a very short reply. 0.62. What is the ratio of the Domestic credit (% of GDP) of Macedonia in 2004 to that in 2008?
Give a very brief answer. 0.5. What is the ratio of the Domestic credit (% of GDP) in Azerbaijan in 2005 to that in 2006?
Ensure brevity in your answer.  0.81. What is the ratio of the Domestic credit (% of GDP) of Burundi in 2005 to that in 2006?
Keep it short and to the point. 0.92. What is the ratio of the Domestic credit (% of GDP) in Comoros in 2005 to that in 2006?
Provide a succinct answer. 1.05. What is the ratio of the Domestic credit (% of GDP) of Macedonia in 2005 to that in 2006?
Your answer should be compact. 0.83. What is the ratio of the Domestic credit (% of GDP) in Azerbaijan in 2005 to that in 2007?
Your answer should be compact. 0.66. What is the ratio of the Domestic credit (% of GDP) of Burundi in 2005 to that in 2007?
Make the answer very short. 0.99. What is the ratio of the Domestic credit (% of GDP) of Comoros in 2005 to that in 2007?
Your answer should be compact. 0.97. What is the ratio of the Domestic credit (% of GDP) of Macedonia in 2005 to that in 2007?
Give a very brief answer. 0.66. What is the ratio of the Domestic credit (% of GDP) in Azerbaijan in 2005 to that in 2008?
Offer a very short reply. 0.61. What is the ratio of the Domestic credit (% of GDP) of Burundi in 2005 to that in 2008?
Your response must be concise. 1.07. What is the ratio of the Domestic credit (% of GDP) in Comoros in 2005 to that in 2008?
Provide a short and direct response. 0.8. What is the ratio of the Domestic credit (% of GDP) of Macedonia in 2005 to that in 2008?
Ensure brevity in your answer.  0.55. What is the ratio of the Domestic credit (% of GDP) in Azerbaijan in 2006 to that in 2007?
Offer a very short reply. 0.82. What is the ratio of the Domestic credit (% of GDP) of Burundi in 2006 to that in 2007?
Make the answer very short. 1.07. What is the ratio of the Domestic credit (% of GDP) of Comoros in 2006 to that in 2007?
Your answer should be very brief. 0.92. What is the ratio of the Domestic credit (% of GDP) of Macedonia in 2006 to that in 2007?
Keep it short and to the point. 0.8. What is the ratio of the Domestic credit (% of GDP) in Azerbaijan in 2006 to that in 2008?
Make the answer very short. 0.75. What is the ratio of the Domestic credit (% of GDP) in Burundi in 2006 to that in 2008?
Ensure brevity in your answer.  1.16. What is the ratio of the Domestic credit (% of GDP) of Comoros in 2006 to that in 2008?
Your answer should be compact. 0.75. What is the ratio of the Domestic credit (% of GDP) of Macedonia in 2006 to that in 2008?
Provide a succinct answer. 0.66. What is the ratio of the Domestic credit (% of GDP) in Azerbaijan in 2007 to that in 2008?
Offer a terse response. 0.92. What is the ratio of the Domestic credit (% of GDP) of Burundi in 2007 to that in 2008?
Provide a short and direct response. 1.08. What is the ratio of the Domestic credit (% of GDP) of Comoros in 2007 to that in 2008?
Make the answer very short. 0.82. What is the ratio of the Domestic credit (% of GDP) of Macedonia in 2007 to that in 2008?
Your answer should be compact. 0.83. What is the difference between the highest and the second highest Domestic credit (% of GDP) in Azerbaijan?
Make the answer very short. 1.27. What is the difference between the highest and the second highest Domestic credit (% of GDP) of Burundi?
Your response must be concise. 0.18. What is the difference between the highest and the second highest Domestic credit (% of GDP) of Comoros?
Your answer should be compact. 1.98. What is the difference between the highest and the second highest Domestic credit (% of GDP) in Macedonia?
Give a very brief answer. 7.18. What is the difference between the highest and the lowest Domestic credit (% of GDP) in Azerbaijan?
Give a very brief answer. 9.95. What is the difference between the highest and the lowest Domestic credit (% of GDP) of Burundi?
Your response must be concise. 6.67. What is the difference between the highest and the lowest Domestic credit (% of GDP) in Comoros?
Offer a very short reply. 4.18. What is the difference between the highest and the lowest Domestic credit (% of GDP) of Macedonia?
Provide a succinct answer. 25.09. 